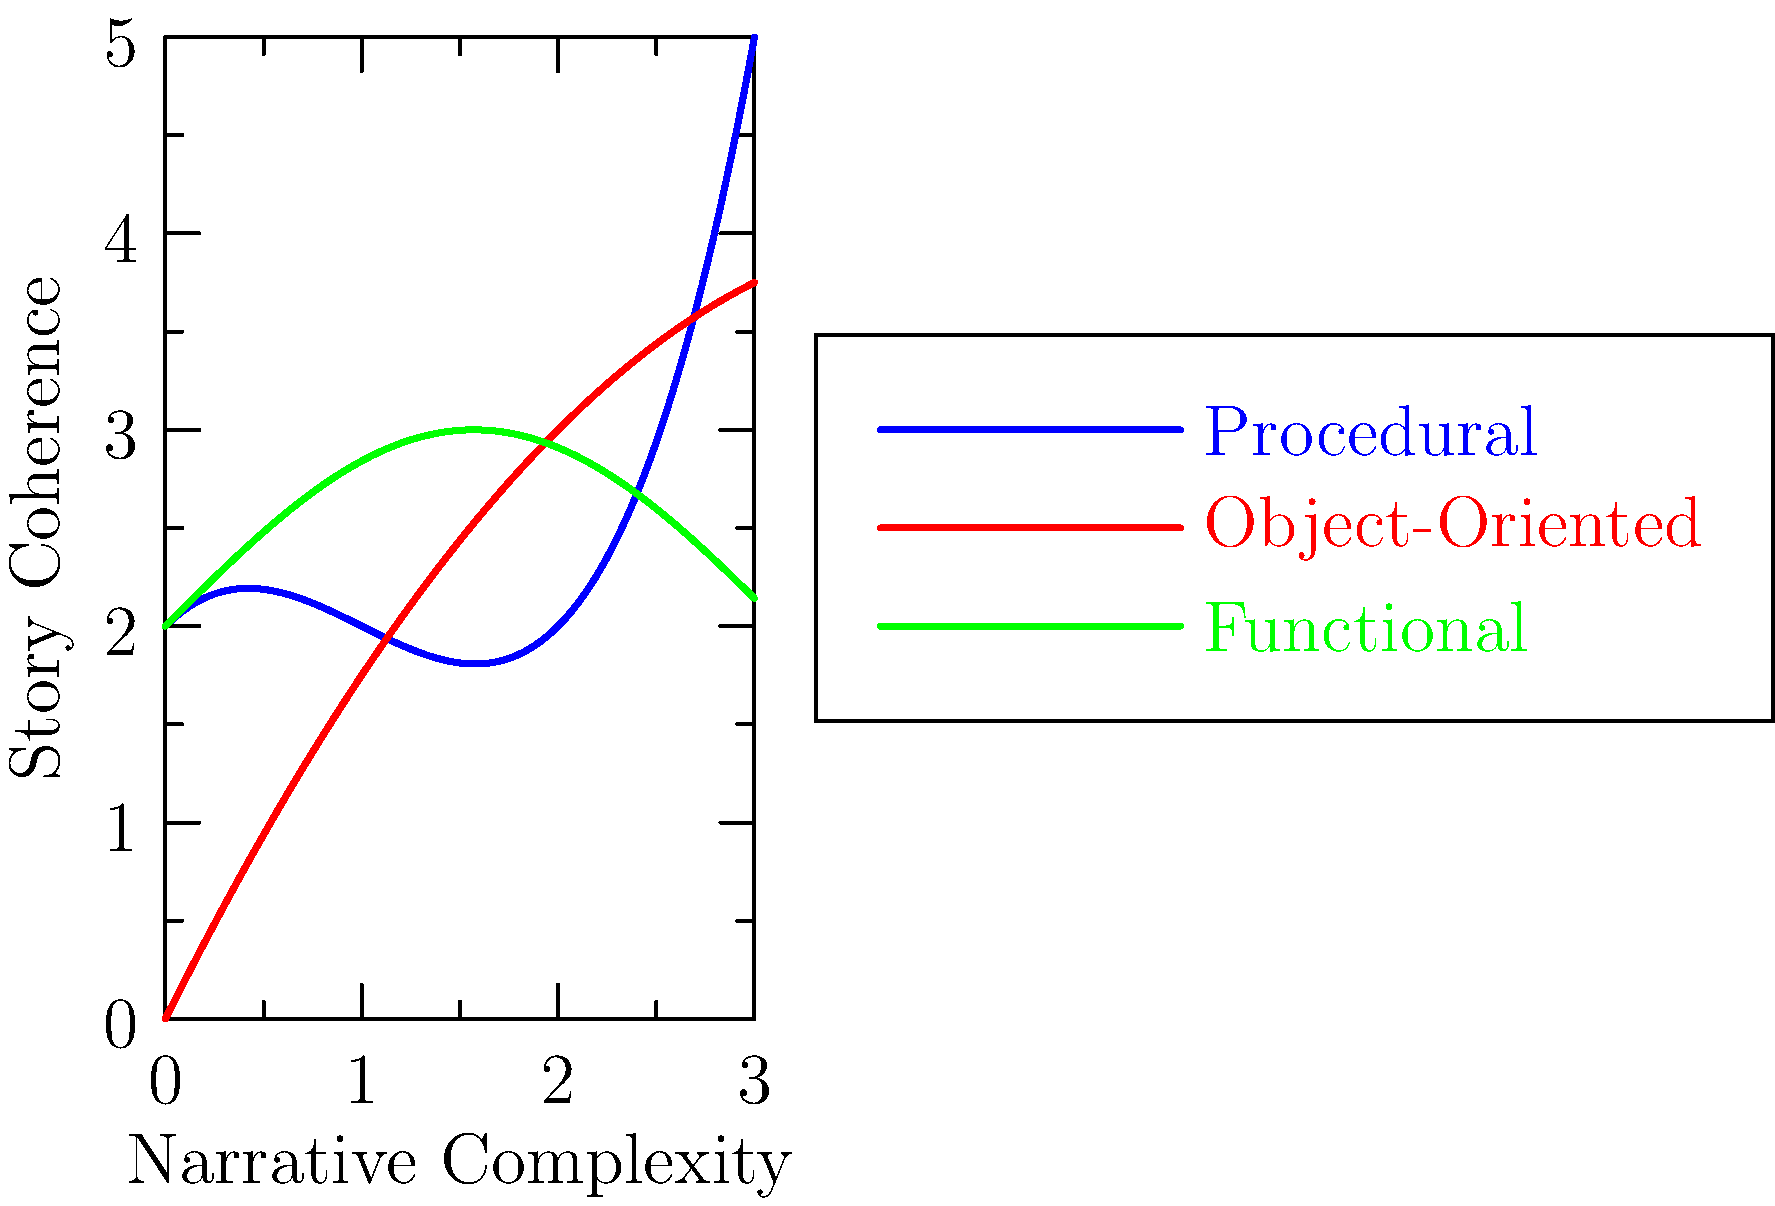Analyze the graph depicting the relationship between narrative complexity and story coherence for different coding paradigms in digital literature. Which paradigm appears to maintain the highest level of story coherence as narrative complexity increases, and how might this influence the creation of interactive narratives in digital environments? To answer this question, we need to examine the graph and interpret its implications for digital literature:

1. The graph shows three curves representing different coding paradigms: Procedural (blue), Object-Oriented (red), and Functional (green).

2. The x-axis represents "Narrative Complexity," while the y-axis represents "Story Coherence."

3. Analyzing each curve:
   a. Procedural (blue): Starts high but drops significantly as complexity increases before rising again.
   b. Object-Oriented (red): Maintains a relatively steady increase in coherence as complexity increases.
   c. Functional (green): Shows a cyclical pattern, with coherence rising and falling as complexity increases.

4. The Object-Oriented paradigm (red line) appears to maintain the highest level of story coherence as narrative complexity increases, showing a consistent upward trend.

5. This could influence interactive narratives in digital environments in several ways:
   a. Object-Oriented approaches might allow for more complex narratives while maintaining coherence.
   b. It could facilitate the creation of intricate, branching storylines that remain comprehensible to the reader/user.
   c. Characters, plot elements, and narrative threads could be treated as objects, allowing for more sophisticated interactions and relationships within the story.
   d. This paradigm might support more scalable and maintainable interactive narratives, as complexity can be added without sacrificing coherence.

6. The implications for digital literature include:
   a. Potential for more immersive and complex interactive storytelling experiences.
   b. Ability to create more dynamic and responsive narrative structures.
   c. Possibility of integrating more diverse narrative elements while maintaining a coherent overall story.
Answer: Object-Oriented paradigm; enables complex, coherent interactive narratives with scalable, maintainable structures and sophisticated character/plot interactions. 